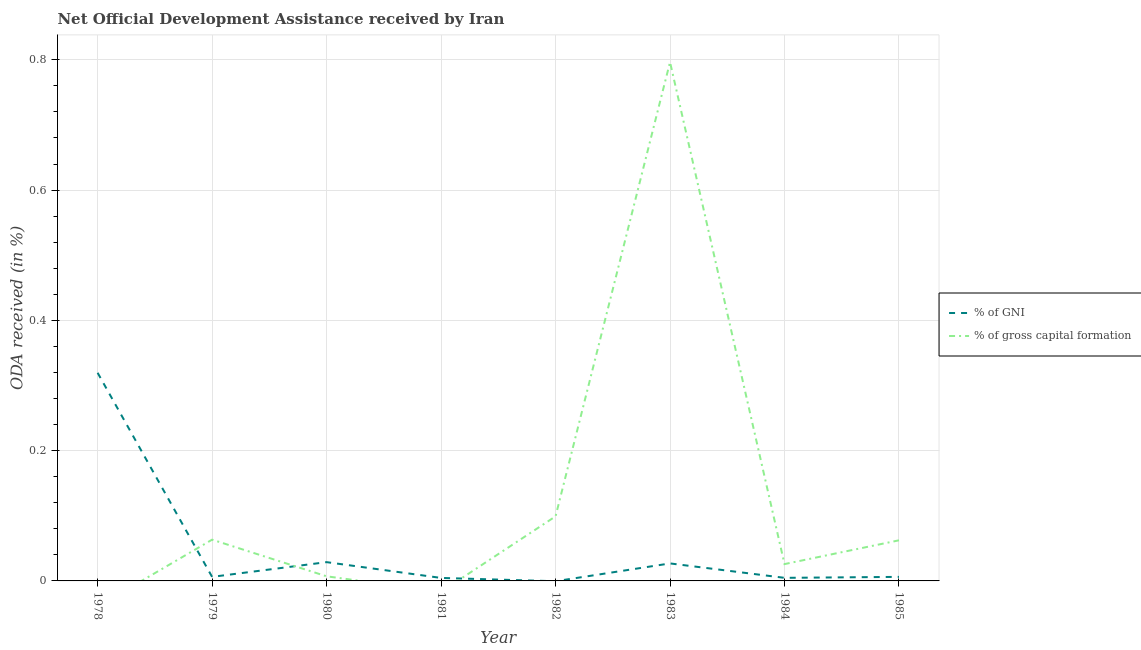How many different coloured lines are there?
Keep it short and to the point. 2. Is the number of lines equal to the number of legend labels?
Your answer should be very brief. No. Across all years, what is the maximum oda received as percentage of gross capital formation?
Your response must be concise. 0.8. What is the total oda received as percentage of gross capital formation in the graph?
Make the answer very short. 1.05. What is the difference between the oda received as percentage of gross capital formation in 1980 and that in 1983?
Make the answer very short. -0.79. What is the difference between the oda received as percentage of gross capital formation in 1980 and the oda received as percentage of gni in 1981?
Provide a short and direct response. 0. What is the average oda received as percentage of gni per year?
Make the answer very short. 0.05. In the year 1980, what is the difference between the oda received as percentage of gross capital formation and oda received as percentage of gni?
Your answer should be very brief. -0.02. What is the ratio of the oda received as percentage of gni in 1979 to that in 1985?
Ensure brevity in your answer.  1. What is the difference between the highest and the second highest oda received as percentage of gni?
Offer a terse response. 0.29. What is the difference between the highest and the lowest oda received as percentage of gni?
Your response must be concise. 0.32. How many lines are there?
Give a very brief answer. 2. What is the difference between two consecutive major ticks on the Y-axis?
Offer a very short reply. 0.2. Does the graph contain any zero values?
Make the answer very short. Yes. Where does the legend appear in the graph?
Offer a very short reply. Center right. What is the title of the graph?
Give a very brief answer. Net Official Development Assistance received by Iran. Does "2012 US$" appear as one of the legend labels in the graph?
Offer a very short reply. No. What is the label or title of the X-axis?
Offer a very short reply. Year. What is the label or title of the Y-axis?
Give a very brief answer. ODA received (in %). What is the ODA received (in %) in % of GNI in 1978?
Your answer should be very brief. 0.32. What is the ODA received (in %) of % of gross capital formation in 1978?
Provide a succinct answer. 0. What is the ODA received (in %) of % of GNI in 1979?
Your response must be concise. 0.01. What is the ODA received (in %) in % of gross capital formation in 1979?
Offer a terse response. 0.06. What is the ODA received (in %) in % of GNI in 1980?
Offer a terse response. 0.03. What is the ODA received (in %) in % of gross capital formation in 1980?
Give a very brief answer. 0.01. What is the ODA received (in %) of % of GNI in 1981?
Your answer should be compact. 0. What is the ODA received (in %) of % of gross capital formation in 1981?
Provide a short and direct response. 0. What is the ODA received (in %) in % of gross capital formation in 1982?
Offer a very short reply. 0.1. What is the ODA received (in %) of % of GNI in 1983?
Your answer should be very brief. 0.03. What is the ODA received (in %) of % of gross capital formation in 1983?
Your answer should be very brief. 0.8. What is the ODA received (in %) of % of GNI in 1984?
Your answer should be compact. 0. What is the ODA received (in %) of % of gross capital formation in 1984?
Provide a succinct answer. 0.03. What is the ODA received (in %) in % of GNI in 1985?
Keep it short and to the point. 0.01. What is the ODA received (in %) of % of gross capital formation in 1985?
Offer a very short reply. 0.06. Across all years, what is the maximum ODA received (in %) in % of GNI?
Give a very brief answer. 0.32. Across all years, what is the maximum ODA received (in %) of % of gross capital formation?
Offer a very short reply. 0.8. Across all years, what is the minimum ODA received (in %) in % of gross capital formation?
Offer a very short reply. 0. What is the total ODA received (in %) of % of GNI in the graph?
Give a very brief answer. 0.4. What is the total ODA received (in %) in % of gross capital formation in the graph?
Provide a short and direct response. 1.05. What is the difference between the ODA received (in %) in % of GNI in 1978 and that in 1979?
Offer a very short reply. 0.31. What is the difference between the ODA received (in %) of % of GNI in 1978 and that in 1980?
Provide a short and direct response. 0.29. What is the difference between the ODA received (in %) of % of GNI in 1978 and that in 1981?
Your answer should be compact. 0.31. What is the difference between the ODA received (in %) of % of GNI in 1978 and that in 1983?
Make the answer very short. 0.29. What is the difference between the ODA received (in %) in % of GNI in 1978 and that in 1984?
Keep it short and to the point. 0.31. What is the difference between the ODA received (in %) in % of GNI in 1978 and that in 1985?
Ensure brevity in your answer.  0.31. What is the difference between the ODA received (in %) of % of GNI in 1979 and that in 1980?
Keep it short and to the point. -0.02. What is the difference between the ODA received (in %) in % of gross capital formation in 1979 and that in 1980?
Keep it short and to the point. 0.06. What is the difference between the ODA received (in %) in % of GNI in 1979 and that in 1981?
Give a very brief answer. 0. What is the difference between the ODA received (in %) in % of gross capital formation in 1979 and that in 1982?
Make the answer very short. -0.04. What is the difference between the ODA received (in %) of % of GNI in 1979 and that in 1983?
Your answer should be compact. -0.02. What is the difference between the ODA received (in %) in % of gross capital formation in 1979 and that in 1983?
Your answer should be very brief. -0.73. What is the difference between the ODA received (in %) of % of GNI in 1979 and that in 1984?
Give a very brief answer. 0. What is the difference between the ODA received (in %) of % of gross capital formation in 1979 and that in 1984?
Your response must be concise. 0.04. What is the difference between the ODA received (in %) in % of GNI in 1980 and that in 1981?
Provide a succinct answer. 0.02. What is the difference between the ODA received (in %) in % of gross capital formation in 1980 and that in 1982?
Give a very brief answer. -0.09. What is the difference between the ODA received (in %) in % of GNI in 1980 and that in 1983?
Provide a short and direct response. 0. What is the difference between the ODA received (in %) in % of gross capital formation in 1980 and that in 1983?
Offer a terse response. -0.79. What is the difference between the ODA received (in %) in % of GNI in 1980 and that in 1984?
Your answer should be compact. 0.02. What is the difference between the ODA received (in %) in % of gross capital formation in 1980 and that in 1984?
Your answer should be very brief. -0.02. What is the difference between the ODA received (in %) of % of GNI in 1980 and that in 1985?
Offer a very short reply. 0.02. What is the difference between the ODA received (in %) in % of gross capital formation in 1980 and that in 1985?
Offer a terse response. -0.06. What is the difference between the ODA received (in %) of % of GNI in 1981 and that in 1983?
Provide a short and direct response. -0.02. What is the difference between the ODA received (in %) in % of GNI in 1981 and that in 1984?
Ensure brevity in your answer.  -0. What is the difference between the ODA received (in %) of % of GNI in 1981 and that in 1985?
Provide a succinct answer. -0. What is the difference between the ODA received (in %) of % of gross capital formation in 1982 and that in 1983?
Ensure brevity in your answer.  -0.7. What is the difference between the ODA received (in %) in % of gross capital formation in 1982 and that in 1984?
Provide a short and direct response. 0.07. What is the difference between the ODA received (in %) in % of gross capital formation in 1982 and that in 1985?
Provide a short and direct response. 0.04. What is the difference between the ODA received (in %) of % of GNI in 1983 and that in 1984?
Offer a very short reply. 0.02. What is the difference between the ODA received (in %) in % of gross capital formation in 1983 and that in 1984?
Your response must be concise. 0.77. What is the difference between the ODA received (in %) in % of GNI in 1983 and that in 1985?
Give a very brief answer. 0.02. What is the difference between the ODA received (in %) of % of gross capital formation in 1983 and that in 1985?
Give a very brief answer. 0.73. What is the difference between the ODA received (in %) in % of GNI in 1984 and that in 1985?
Make the answer very short. -0. What is the difference between the ODA received (in %) in % of gross capital formation in 1984 and that in 1985?
Make the answer very short. -0.04. What is the difference between the ODA received (in %) of % of GNI in 1978 and the ODA received (in %) of % of gross capital formation in 1979?
Ensure brevity in your answer.  0.26. What is the difference between the ODA received (in %) in % of GNI in 1978 and the ODA received (in %) in % of gross capital formation in 1980?
Provide a succinct answer. 0.31. What is the difference between the ODA received (in %) of % of GNI in 1978 and the ODA received (in %) of % of gross capital formation in 1982?
Your answer should be very brief. 0.22. What is the difference between the ODA received (in %) of % of GNI in 1978 and the ODA received (in %) of % of gross capital formation in 1983?
Make the answer very short. -0.48. What is the difference between the ODA received (in %) in % of GNI in 1978 and the ODA received (in %) in % of gross capital formation in 1984?
Offer a very short reply. 0.29. What is the difference between the ODA received (in %) in % of GNI in 1978 and the ODA received (in %) in % of gross capital formation in 1985?
Offer a very short reply. 0.26. What is the difference between the ODA received (in %) of % of GNI in 1979 and the ODA received (in %) of % of gross capital formation in 1980?
Offer a very short reply. -0. What is the difference between the ODA received (in %) in % of GNI in 1979 and the ODA received (in %) in % of gross capital formation in 1982?
Provide a short and direct response. -0.09. What is the difference between the ODA received (in %) of % of GNI in 1979 and the ODA received (in %) of % of gross capital formation in 1983?
Keep it short and to the point. -0.79. What is the difference between the ODA received (in %) of % of GNI in 1979 and the ODA received (in %) of % of gross capital formation in 1984?
Offer a very short reply. -0.02. What is the difference between the ODA received (in %) of % of GNI in 1979 and the ODA received (in %) of % of gross capital formation in 1985?
Make the answer very short. -0.06. What is the difference between the ODA received (in %) in % of GNI in 1980 and the ODA received (in %) in % of gross capital formation in 1982?
Keep it short and to the point. -0.07. What is the difference between the ODA received (in %) of % of GNI in 1980 and the ODA received (in %) of % of gross capital formation in 1983?
Ensure brevity in your answer.  -0.77. What is the difference between the ODA received (in %) in % of GNI in 1980 and the ODA received (in %) in % of gross capital formation in 1984?
Provide a succinct answer. 0. What is the difference between the ODA received (in %) in % of GNI in 1980 and the ODA received (in %) in % of gross capital formation in 1985?
Give a very brief answer. -0.03. What is the difference between the ODA received (in %) of % of GNI in 1981 and the ODA received (in %) of % of gross capital formation in 1982?
Your answer should be very brief. -0.09. What is the difference between the ODA received (in %) of % of GNI in 1981 and the ODA received (in %) of % of gross capital formation in 1983?
Keep it short and to the point. -0.79. What is the difference between the ODA received (in %) in % of GNI in 1981 and the ODA received (in %) in % of gross capital formation in 1984?
Offer a very short reply. -0.02. What is the difference between the ODA received (in %) of % of GNI in 1981 and the ODA received (in %) of % of gross capital formation in 1985?
Offer a terse response. -0.06. What is the difference between the ODA received (in %) in % of GNI in 1983 and the ODA received (in %) in % of gross capital formation in 1984?
Provide a short and direct response. 0. What is the difference between the ODA received (in %) of % of GNI in 1983 and the ODA received (in %) of % of gross capital formation in 1985?
Your response must be concise. -0.04. What is the difference between the ODA received (in %) of % of GNI in 1984 and the ODA received (in %) of % of gross capital formation in 1985?
Ensure brevity in your answer.  -0.06. What is the average ODA received (in %) in % of GNI per year?
Give a very brief answer. 0.05. What is the average ODA received (in %) of % of gross capital formation per year?
Ensure brevity in your answer.  0.13. In the year 1979, what is the difference between the ODA received (in %) in % of GNI and ODA received (in %) in % of gross capital formation?
Make the answer very short. -0.06. In the year 1980, what is the difference between the ODA received (in %) in % of GNI and ODA received (in %) in % of gross capital formation?
Your answer should be compact. 0.02. In the year 1983, what is the difference between the ODA received (in %) in % of GNI and ODA received (in %) in % of gross capital formation?
Make the answer very short. -0.77. In the year 1984, what is the difference between the ODA received (in %) of % of GNI and ODA received (in %) of % of gross capital formation?
Your response must be concise. -0.02. In the year 1985, what is the difference between the ODA received (in %) in % of GNI and ODA received (in %) in % of gross capital formation?
Offer a terse response. -0.06. What is the ratio of the ODA received (in %) in % of GNI in 1978 to that in 1979?
Ensure brevity in your answer.  51.4. What is the ratio of the ODA received (in %) of % of GNI in 1978 to that in 1980?
Provide a short and direct response. 11.08. What is the ratio of the ODA received (in %) in % of GNI in 1978 to that in 1981?
Make the answer very short. 69.54. What is the ratio of the ODA received (in %) in % of GNI in 1978 to that in 1983?
Your answer should be very brief. 11.89. What is the ratio of the ODA received (in %) in % of GNI in 1978 to that in 1984?
Give a very brief answer. 67.69. What is the ratio of the ODA received (in %) of % of GNI in 1978 to that in 1985?
Offer a terse response. 51.4. What is the ratio of the ODA received (in %) in % of GNI in 1979 to that in 1980?
Give a very brief answer. 0.22. What is the ratio of the ODA received (in %) of % of gross capital formation in 1979 to that in 1980?
Keep it short and to the point. 8.93. What is the ratio of the ODA received (in %) in % of GNI in 1979 to that in 1981?
Ensure brevity in your answer.  1.35. What is the ratio of the ODA received (in %) of % of gross capital formation in 1979 to that in 1982?
Make the answer very short. 0.64. What is the ratio of the ODA received (in %) in % of GNI in 1979 to that in 1983?
Your answer should be compact. 0.23. What is the ratio of the ODA received (in %) in % of gross capital formation in 1979 to that in 1983?
Keep it short and to the point. 0.08. What is the ratio of the ODA received (in %) of % of GNI in 1979 to that in 1984?
Your answer should be very brief. 1.32. What is the ratio of the ODA received (in %) of % of gross capital formation in 1979 to that in 1984?
Your answer should be very brief. 2.45. What is the ratio of the ODA received (in %) of % of gross capital formation in 1979 to that in 1985?
Your answer should be very brief. 1.02. What is the ratio of the ODA received (in %) in % of GNI in 1980 to that in 1981?
Your answer should be compact. 6.28. What is the ratio of the ODA received (in %) in % of gross capital formation in 1980 to that in 1982?
Make the answer very short. 0.07. What is the ratio of the ODA received (in %) of % of GNI in 1980 to that in 1983?
Make the answer very short. 1.07. What is the ratio of the ODA received (in %) in % of gross capital formation in 1980 to that in 1983?
Provide a succinct answer. 0.01. What is the ratio of the ODA received (in %) of % of GNI in 1980 to that in 1984?
Your answer should be compact. 6.11. What is the ratio of the ODA received (in %) of % of gross capital formation in 1980 to that in 1984?
Provide a succinct answer. 0.27. What is the ratio of the ODA received (in %) in % of GNI in 1980 to that in 1985?
Offer a terse response. 4.64. What is the ratio of the ODA received (in %) in % of gross capital formation in 1980 to that in 1985?
Your answer should be compact. 0.11. What is the ratio of the ODA received (in %) in % of GNI in 1981 to that in 1983?
Your response must be concise. 0.17. What is the ratio of the ODA received (in %) of % of GNI in 1981 to that in 1984?
Ensure brevity in your answer.  0.97. What is the ratio of the ODA received (in %) of % of GNI in 1981 to that in 1985?
Give a very brief answer. 0.74. What is the ratio of the ODA received (in %) of % of gross capital formation in 1982 to that in 1983?
Offer a terse response. 0.12. What is the ratio of the ODA received (in %) of % of gross capital formation in 1982 to that in 1984?
Your answer should be very brief. 3.84. What is the ratio of the ODA received (in %) of % of gross capital formation in 1982 to that in 1985?
Provide a short and direct response. 1.59. What is the ratio of the ODA received (in %) in % of GNI in 1983 to that in 1984?
Make the answer very short. 5.69. What is the ratio of the ODA received (in %) of % of gross capital formation in 1983 to that in 1984?
Your answer should be compact. 30.83. What is the ratio of the ODA received (in %) in % of GNI in 1983 to that in 1985?
Provide a succinct answer. 4.32. What is the ratio of the ODA received (in %) in % of gross capital formation in 1983 to that in 1985?
Your answer should be very brief. 12.78. What is the ratio of the ODA received (in %) in % of GNI in 1984 to that in 1985?
Provide a succinct answer. 0.76. What is the ratio of the ODA received (in %) of % of gross capital formation in 1984 to that in 1985?
Your answer should be compact. 0.41. What is the difference between the highest and the second highest ODA received (in %) of % of GNI?
Give a very brief answer. 0.29. What is the difference between the highest and the second highest ODA received (in %) in % of gross capital formation?
Give a very brief answer. 0.7. What is the difference between the highest and the lowest ODA received (in %) in % of GNI?
Keep it short and to the point. 0.32. What is the difference between the highest and the lowest ODA received (in %) in % of gross capital formation?
Keep it short and to the point. 0.8. 